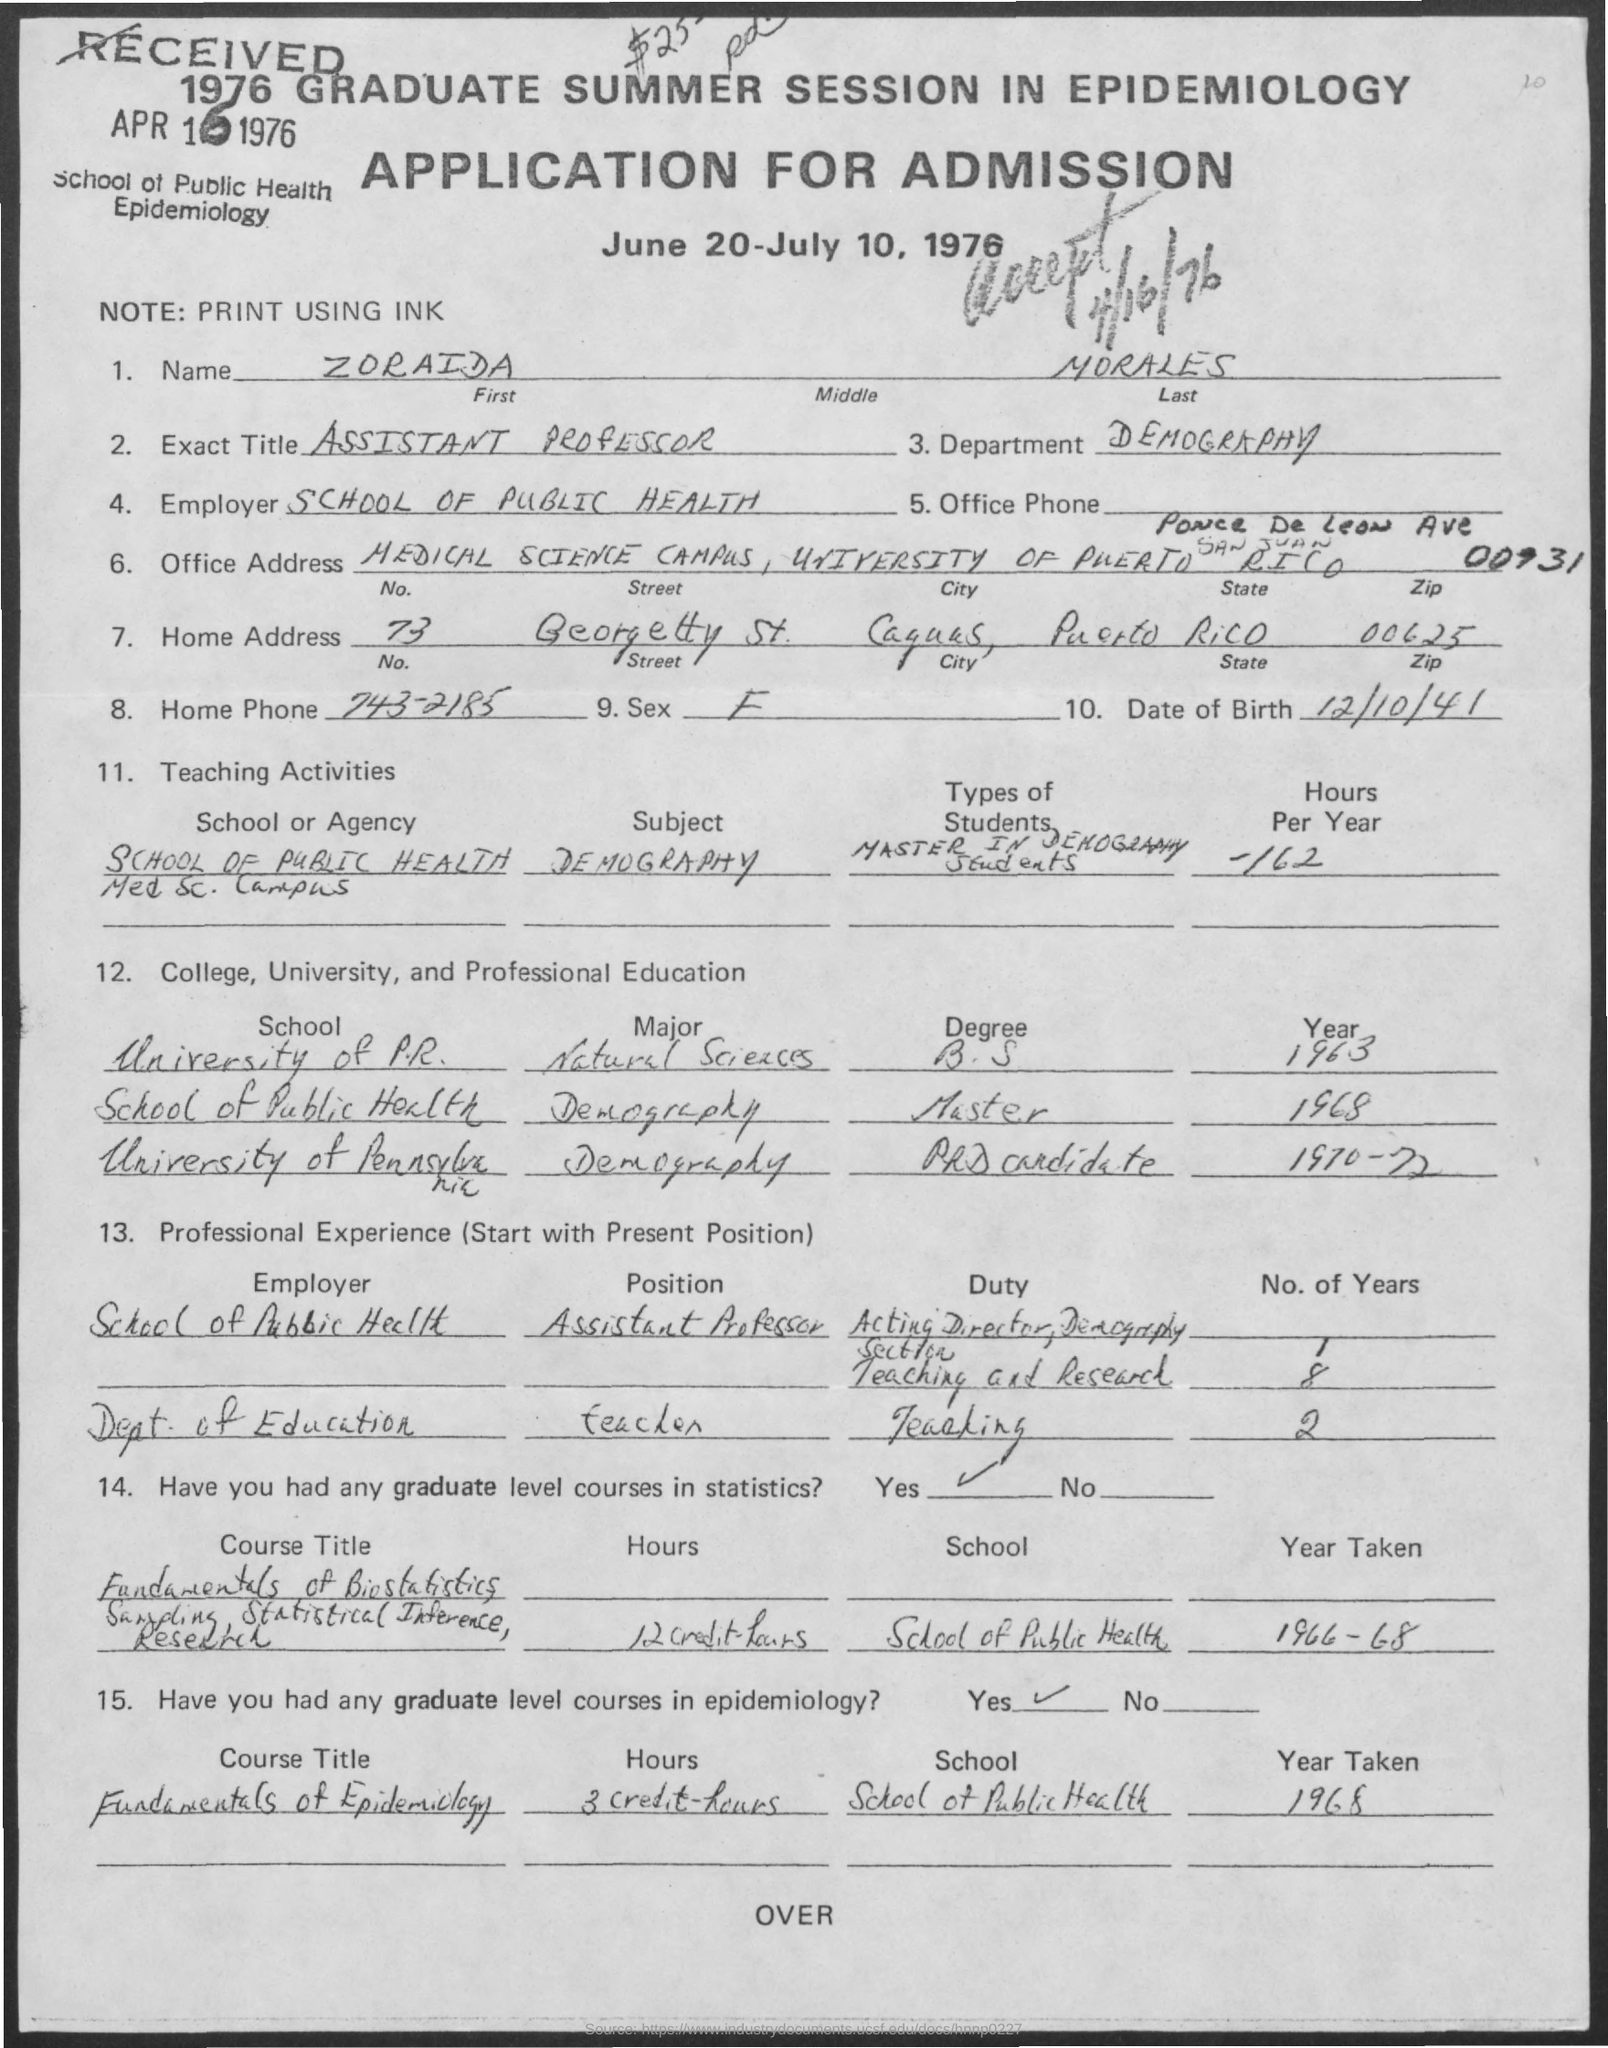List a handful of essential elements in this visual. In the year 1968, Zoraida Morales completed her Master's degree in Demography. The applicant's first name is Zoraida. The inquiry regarding the home phone number of Zoraida Morales, which is 743-2185, was made. The date of birth of Zoraida Morales is October 12, 1941. The application was submitted on April 16, 1976, and is now considered accepted. 